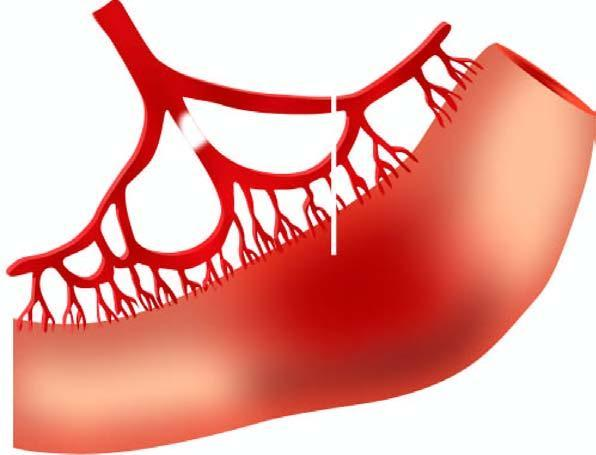what is not clear-cut?
Answer the question using a single word or phrase. Line of demarcation between gangrenous segment and the viable bowel 